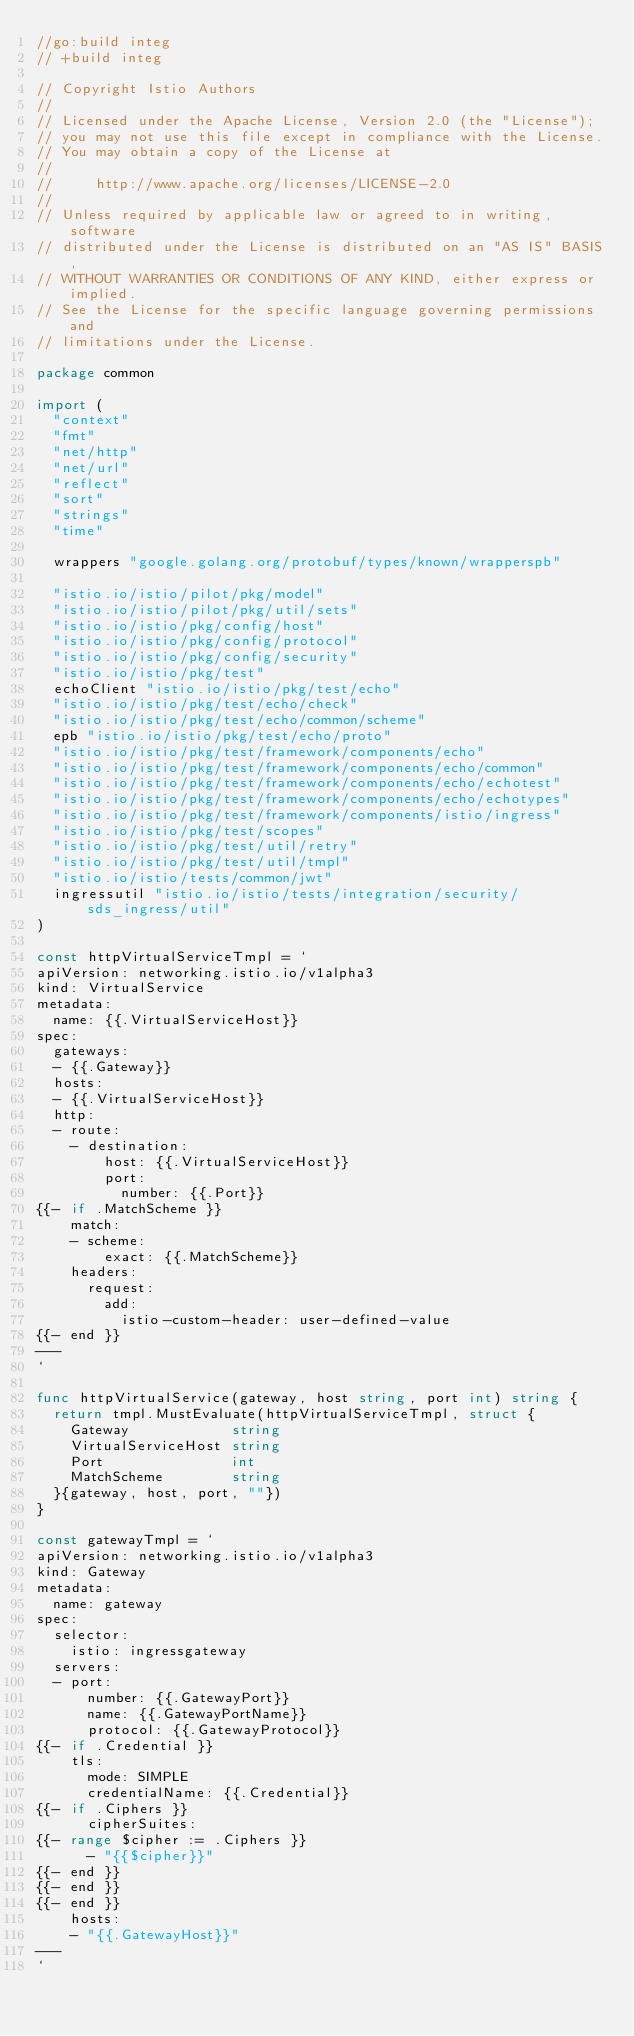<code> <loc_0><loc_0><loc_500><loc_500><_Go_>//go:build integ
// +build integ

// Copyright Istio Authors
//
// Licensed under the Apache License, Version 2.0 (the "License");
// you may not use this file except in compliance with the License.
// You may obtain a copy of the License at
//
//     http://www.apache.org/licenses/LICENSE-2.0
//
// Unless required by applicable law or agreed to in writing, software
// distributed under the License is distributed on an "AS IS" BASIS,
// WITHOUT WARRANTIES OR CONDITIONS OF ANY KIND, either express or implied.
// See the License for the specific language governing permissions and
// limitations under the License.

package common

import (
	"context"
	"fmt"
	"net/http"
	"net/url"
	"reflect"
	"sort"
	"strings"
	"time"

	wrappers "google.golang.org/protobuf/types/known/wrapperspb"

	"istio.io/istio/pilot/pkg/model"
	"istio.io/istio/pilot/pkg/util/sets"
	"istio.io/istio/pkg/config/host"
	"istio.io/istio/pkg/config/protocol"
	"istio.io/istio/pkg/config/security"
	"istio.io/istio/pkg/test"
	echoClient "istio.io/istio/pkg/test/echo"
	"istio.io/istio/pkg/test/echo/check"
	"istio.io/istio/pkg/test/echo/common/scheme"
	epb "istio.io/istio/pkg/test/echo/proto"
	"istio.io/istio/pkg/test/framework/components/echo"
	"istio.io/istio/pkg/test/framework/components/echo/common"
	"istio.io/istio/pkg/test/framework/components/echo/echotest"
	"istio.io/istio/pkg/test/framework/components/echo/echotypes"
	"istio.io/istio/pkg/test/framework/components/istio/ingress"
	"istio.io/istio/pkg/test/scopes"
	"istio.io/istio/pkg/test/util/retry"
	"istio.io/istio/pkg/test/util/tmpl"
	"istio.io/istio/tests/common/jwt"
	ingressutil "istio.io/istio/tests/integration/security/sds_ingress/util"
)

const httpVirtualServiceTmpl = `
apiVersion: networking.istio.io/v1alpha3
kind: VirtualService
metadata:
  name: {{.VirtualServiceHost}}
spec:
  gateways:
  - {{.Gateway}}
  hosts:
  - {{.VirtualServiceHost}}
  http:
  - route:
    - destination:
        host: {{.VirtualServiceHost}}
        port:
          number: {{.Port}}
{{- if .MatchScheme }}
    match:
    - scheme:
        exact: {{.MatchScheme}}
    headers:
      request:
        add:
          istio-custom-header: user-defined-value
{{- end }}
---
`

func httpVirtualService(gateway, host string, port int) string {
	return tmpl.MustEvaluate(httpVirtualServiceTmpl, struct {
		Gateway            string
		VirtualServiceHost string
		Port               int
		MatchScheme        string
	}{gateway, host, port, ""})
}

const gatewayTmpl = `
apiVersion: networking.istio.io/v1alpha3
kind: Gateway
metadata:
  name: gateway
spec:
  selector:
    istio: ingressgateway
  servers:
  - port:
      number: {{.GatewayPort}}
      name: {{.GatewayPortName}}
      protocol: {{.GatewayProtocol}}
{{- if .Credential }}
    tls:
      mode: SIMPLE
      credentialName: {{.Credential}}
{{- if .Ciphers }}
      cipherSuites:
{{- range $cipher := .Ciphers }}
      - "{{$cipher}}"
{{- end }}
{{- end }}
{{- end }}
    hosts:
    - "{{.GatewayHost}}"
---
`
</code> 